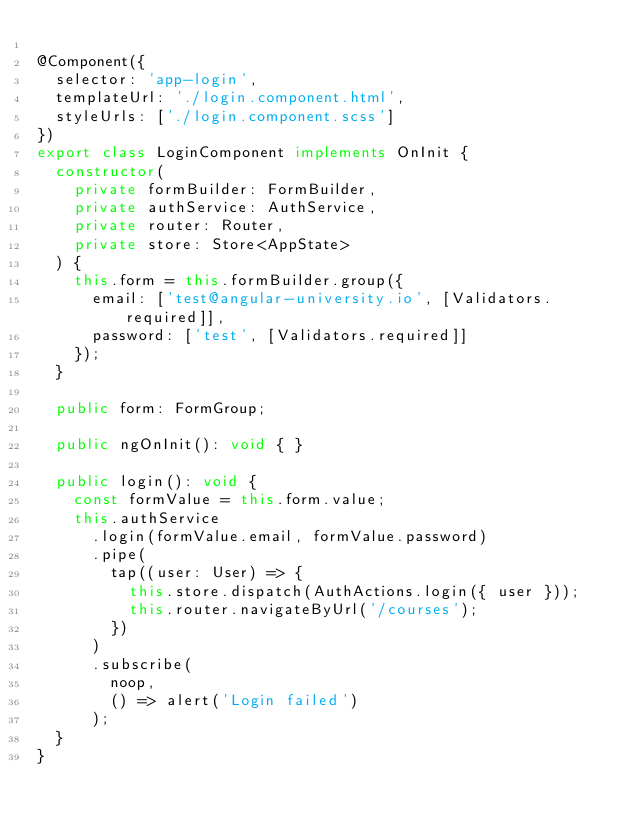<code> <loc_0><loc_0><loc_500><loc_500><_TypeScript_>
@Component({
  selector: 'app-login',
  templateUrl: './login.component.html',
  styleUrls: ['./login.component.scss']
})
export class LoginComponent implements OnInit {
  constructor(
    private formBuilder: FormBuilder,
    private authService: AuthService,
    private router: Router,
    private store: Store<AppState>
  ) {
    this.form = this.formBuilder.group({
      email: ['test@angular-university.io', [Validators.required]],
      password: ['test', [Validators.required]]
    });
  }

  public form: FormGroup;

  public ngOnInit(): void { }

  public login(): void {
    const formValue = this.form.value;
    this.authService
      .login(formValue.email, formValue.password)
      .pipe(
        tap((user: User) => {
          this.store.dispatch(AuthActions.login({ user }));
          this.router.navigateByUrl('/courses');
        })
      )
      .subscribe(
        noop,
        () => alert('Login failed')
      );
  }
}
</code> 